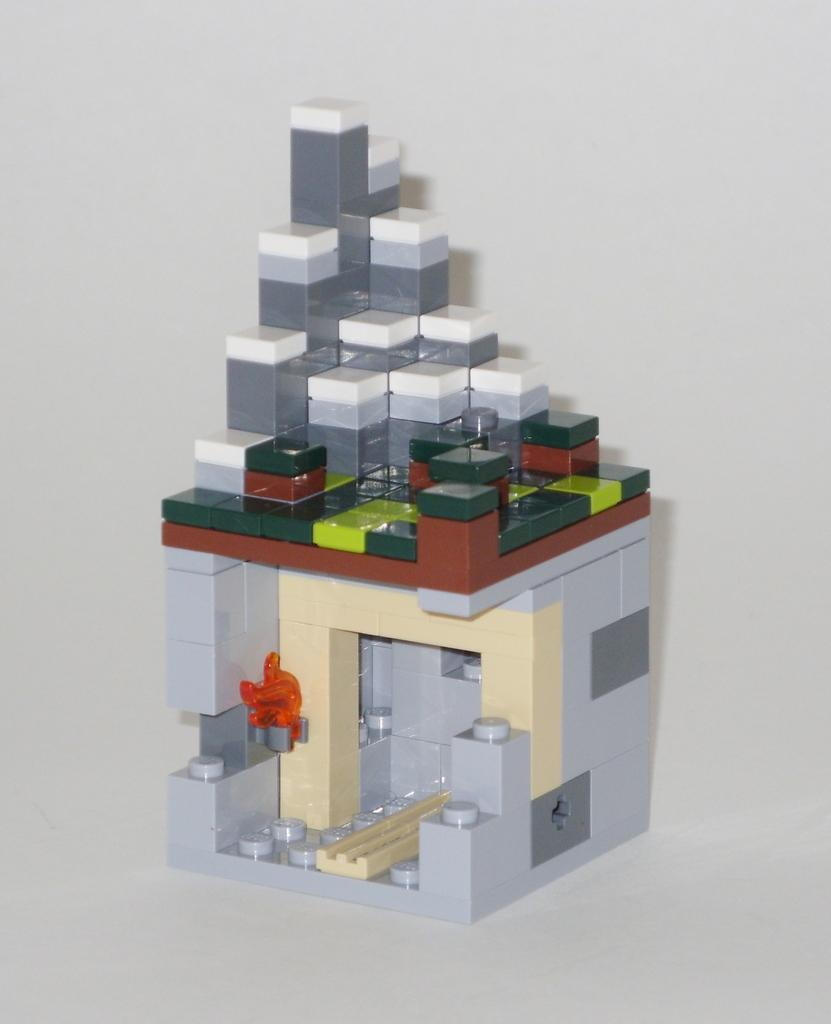What type of structure is depicted in the image? There is a structure of a house in the image. What material is the structure made of? The structure is made with Lego. Where is the Lego house placed? The Lego structure is placed on a surface. What type of comb is used to style the Lego house in the image? There is no comb present in the image, as it features a Lego house structure. 